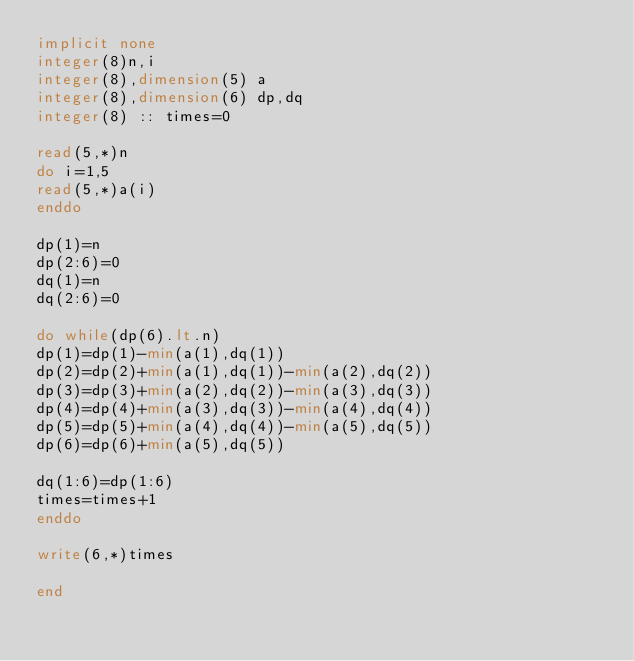Convert code to text. <code><loc_0><loc_0><loc_500><loc_500><_FORTRAN_>implicit none
integer(8)n,i
integer(8),dimension(5) a
integer(8),dimension(6) dp,dq
integer(8) :: times=0

read(5,*)n
do i=1,5
read(5,*)a(i)
enddo

dp(1)=n
dp(2:6)=0
dq(1)=n
dq(2:6)=0

do while(dp(6).lt.n)
dp(1)=dp(1)-min(a(1),dq(1))
dp(2)=dp(2)+min(a(1),dq(1))-min(a(2),dq(2))
dp(3)=dp(3)+min(a(2),dq(2))-min(a(3),dq(3))
dp(4)=dp(4)+min(a(3),dq(3))-min(a(4),dq(4))
dp(5)=dp(5)+min(a(4),dq(4))-min(a(5),dq(5))
dp(6)=dp(6)+min(a(5),dq(5))

dq(1:6)=dp(1:6)
times=times+1
enddo

write(6,*)times

end</code> 